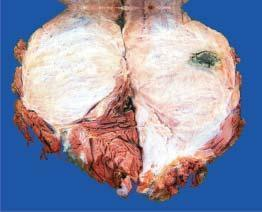what is cut surface?
Answer the question using a single word or phrase. Grey-white fleshy with areas of haemorrhage and necrosis 